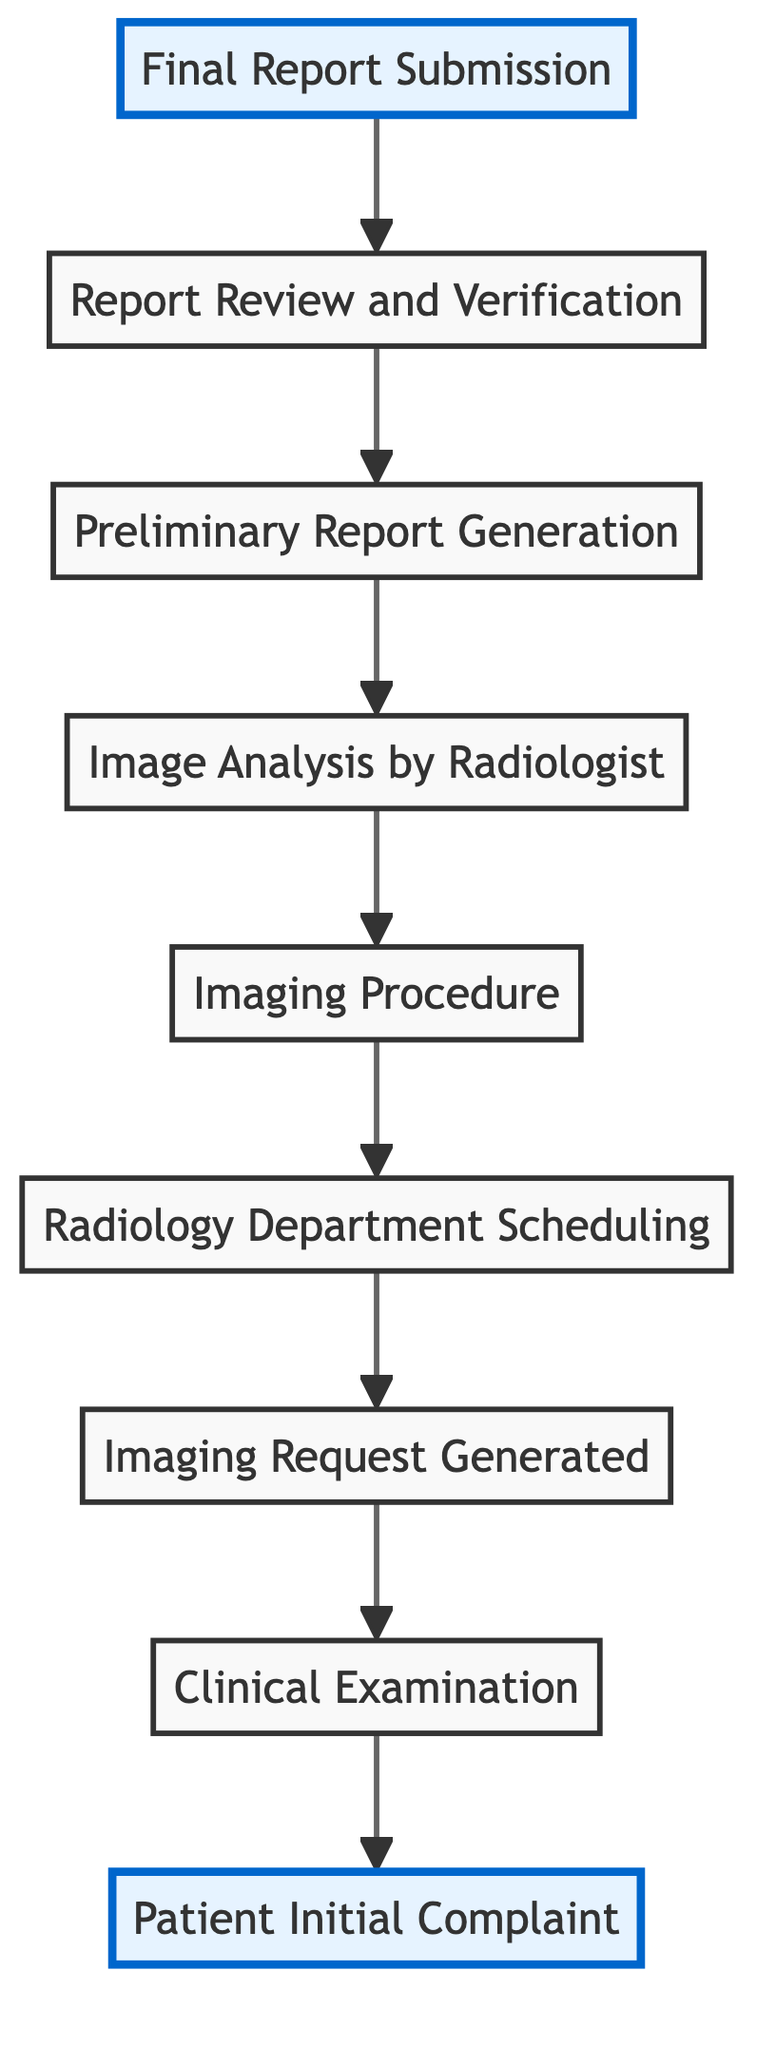What is the first step in the patient diagnosis process? The diagram indicates that the first step is "Patient Initial Complaint." This is confirmed by the flow starting from the bottom, where the first node represents the initial action taken in the diagnosis process.
Answer: Patient Initial Complaint How many elements are in the diagnosis process flowchart? To determine the number of elements, you can count each unique step represented in the diagram. There are nine distinct elements from "Patient Initial Complaint" to "Final Report Submission."
Answer: 9 What comes after the Imaging Request Generated? The diagram shows that after "Imaging Request Generated," the next step is "Radiology Department Scheduling." This is indicated by the directional flow from one element to the next in the chart.
Answer: Radiology Department Scheduling Who reviews and verifies the preliminary report? The diagram specifies that a "Senior radiologist or quality control" is responsible for this task. The flow indicates this step leads from preliminary report generation to the review and verification process.
Answer: Senior radiologist What is the output of the process after the Report Review and Verification? According to the flowchart, the output after this step is the "Final Report Submission." The flow moves from review and verification directly to the final report submission in a sequential manner.
Answer: Final Report Submission What is the primary action that takes place at the sixth step? The sixth step describes "Image Analysis by Radiologist." This is the key action taken at this point in the process where the radiologist interprets the imaging results.
Answer: Image Analysis by Radiologist Which step is directly before the Final Report Submission? Examining the flow of the process shows that "Report Review and Verification" is the step right before "Final Report Submission," as confirmed by the direct connection in the chart.
Answer: Report Review and Verification How many transitional steps are there in the diagram? To find the number of transitional steps, you observe that there are eight flows connecting the nine elements, indicating the transitions between each step in the diagnosis process.
Answer: 8 What is the last action performed in the diagnosis process? The diagram clearly illustrates that the last action performed in the diagnosis process is "Final Report Submission." This step concludes the flow of the patient diagnosis process.
Answer: Final Report Submission 